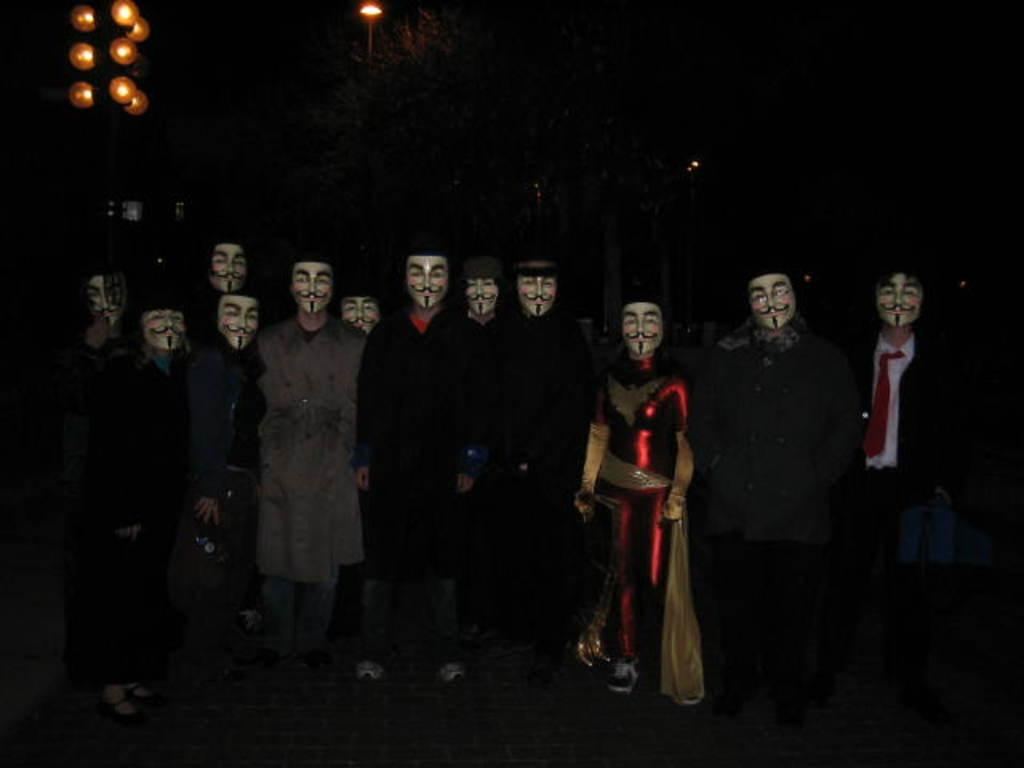How many people are in the image? There is a group of people in the image. What are the people wearing on their faces? The people are wearing face masks. Where are the people standing in the image? The people are standing on a path. What can be seen in the background of the image? There is a dark view in the background of the image, with trees, lights, and other objects visible. What grade of produce can be seen in the image? There is no produce present in the image, so it is not possible to determine the grade. 